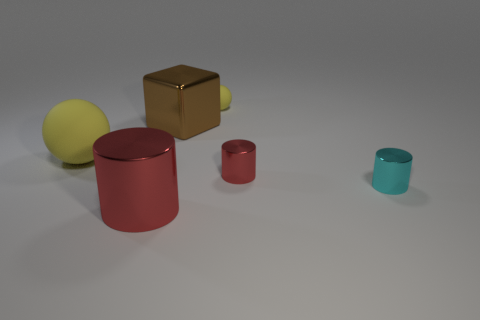What size is the cyan cylinder?
Make the answer very short. Small. What is the size of the metal object in front of the cyan metal thing?
Provide a short and direct response. Large. There is a shiny object that is to the left of the tiny sphere and behind the large red metallic object; what shape is it?
Provide a short and direct response. Cube. How many other objects are the same shape as the brown metal thing?
Provide a succinct answer. 0. What color is the cylinder that is the same size as the brown block?
Your answer should be compact. Red. What number of objects are small cyan cylinders or purple rubber balls?
Provide a short and direct response. 1. Are there any rubber spheres in front of the big cylinder?
Your response must be concise. No. Is there a brown ball that has the same material as the big cylinder?
Keep it short and to the point. No. The rubber object that is the same color as the tiny sphere is what size?
Provide a short and direct response. Large. How many cylinders are blue objects or metallic things?
Keep it short and to the point. 3. 